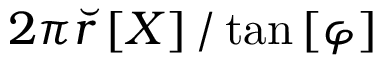Convert formula to latex. <formula><loc_0><loc_0><loc_500><loc_500>2 \pi \breve { r } \left [ X \right ] / \tan \left [ \varphi \right ]</formula> 